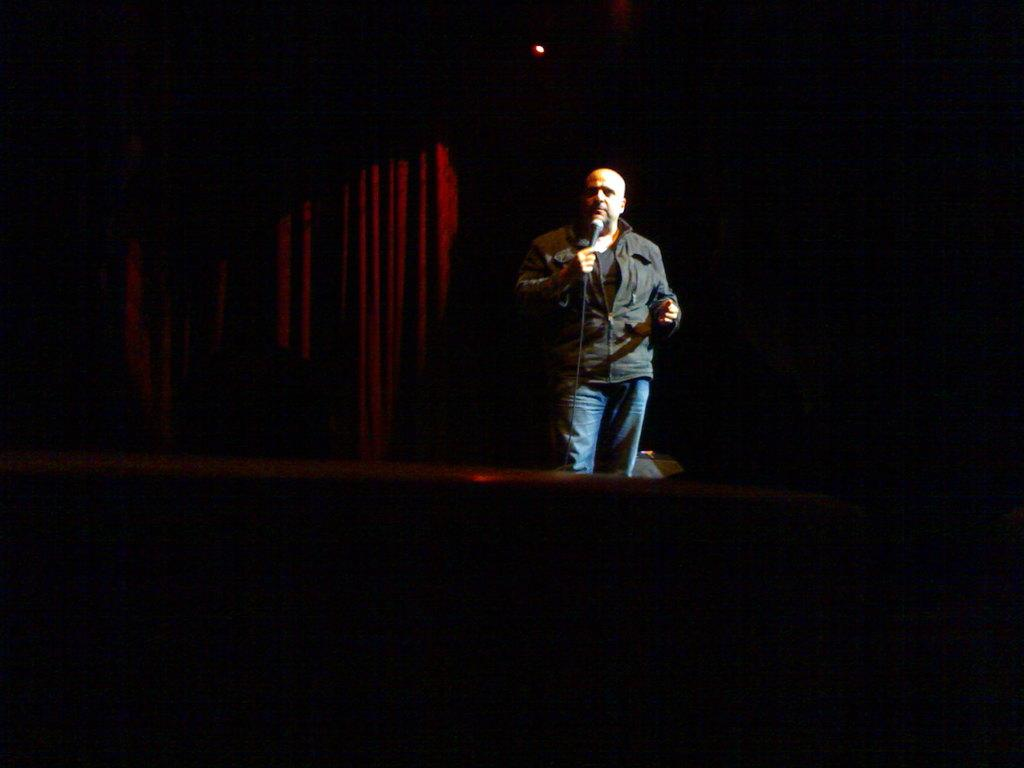Who is the main subject in the image? There is a man in the image. What is the man doing in the image? The man is speaking into a microphone. What can be seen at the top of the image? There is a light at the top of the image. What type of background is visible in the image? There are curtains in the background of the image. What type of yak can be seen in the background of the image? There is no yak present in the image; the background consists of curtains. 